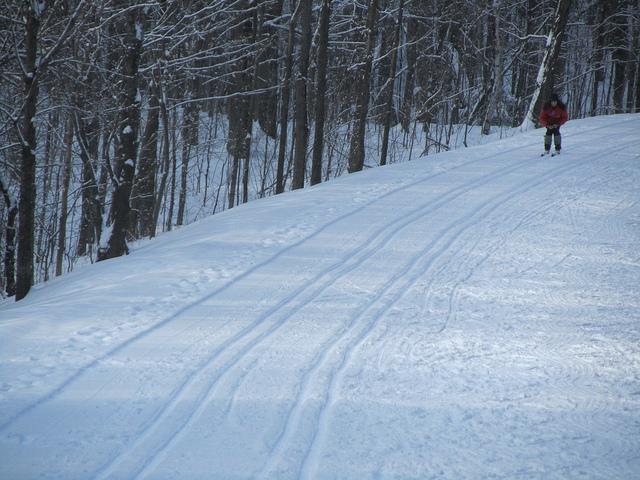What color jacket is the person wearing?
Give a very brief answer. Red. Have other people traveled this way before?
Be succinct. Yes. How many people are going downhill?
Keep it brief. 1. What color winter coat is the girl wearing?
Quick response, please. Red. 